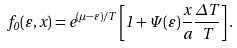<formula> <loc_0><loc_0><loc_500><loc_500>f _ { 0 } ( \varepsilon , x ) = e ^ { ( \mu - \varepsilon ) / T } \left [ 1 + \Psi ( \varepsilon ) \frac { x } { a } \frac { \Delta T } { T } \right ] .</formula> 